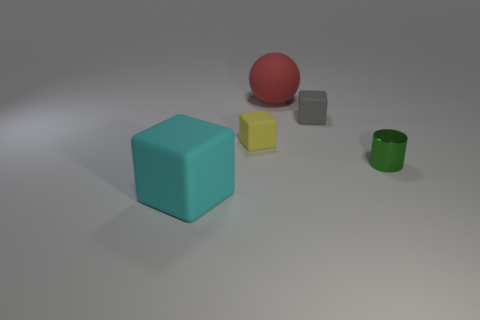Add 1 large matte cubes. How many objects exist? 6 Add 4 rubber balls. How many rubber balls exist? 5 Subtract all cyan blocks. How many blocks are left? 2 Subtract all small rubber cubes. How many cubes are left? 1 Subtract 0 blue cylinders. How many objects are left? 5 Subtract all cylinders. How many objects are left? 4 Subtract 1 cubes. How many cubes are left? 2 Subtract all yellow cylinders. Subtract all purple cubes. How many cylinders are left? 1 Subtract all blue cubes. How many cyan spheres are left? 0 Subtract all tiny gray objects. Subtract all large cyan rubber spheres. How many objects are left? 4 